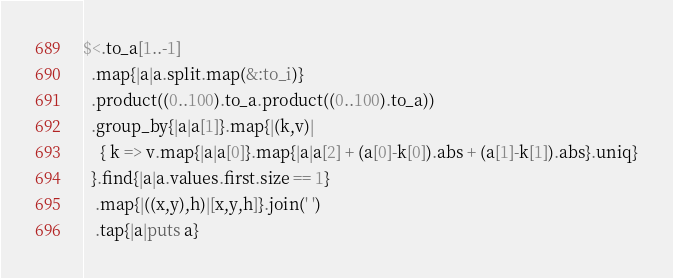<code> <loc_0><loc_0><loc_500><loc_500><_Ruby_>$<.to_a[1..-1]
  .map{|a|a.split.map(&:to_i)}
  .product((0..100).to_a.product((0..100).to_a))
  .group_by{|a|a[1]}.map{|(k,v)|
    { k => v.map{|a|a[0]}.map{|a|a[2] + (a[0]-k[0]).abs + (a[1]-k[1]).abs}.uniq}
  }.find{|a|a.values.first.size == 1}
   .map{|((x,y),h)|[x,y,h]}.join(' ')
   .tap{|a|puts a}
</code> 